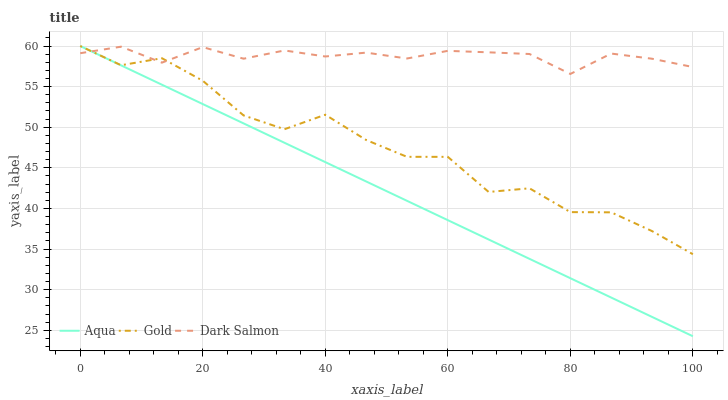Does Aqua have the minimum area under the curve?
Answer yes or no. Yes. Does Dark Salmon have the maximum area under the curve?
Answer yes or no. Yes. Does Gold have the minimum area under the curve?
Answer yes or no. No. Does Gold have the maximum area under the curve?
Answer yes or no. No. Is Aqua the smoothest?
Answer yes or no. Yes. Is Gold the roughest?
Answer yes or no. Yes. Is Dark Salmon the smoothest?
Answer yes or no. No. Is Dark Salmon the roughest?
Answer yes or no. No. Does Gold have the lowest value?
Answer yes or no. No. Does Gold have the highest value?
Answer yes or no. Yes. Does Dark Salmon have the highest value?
Answer yes or no. No. Does Aqua intersect Dark Salmon?
Answer yes or no. Yes. Is Aqua less than Dark Salmon?
Answer yes or no. No. Is Aqua greater than Dark Salmon?
Answer yes or no. No. 